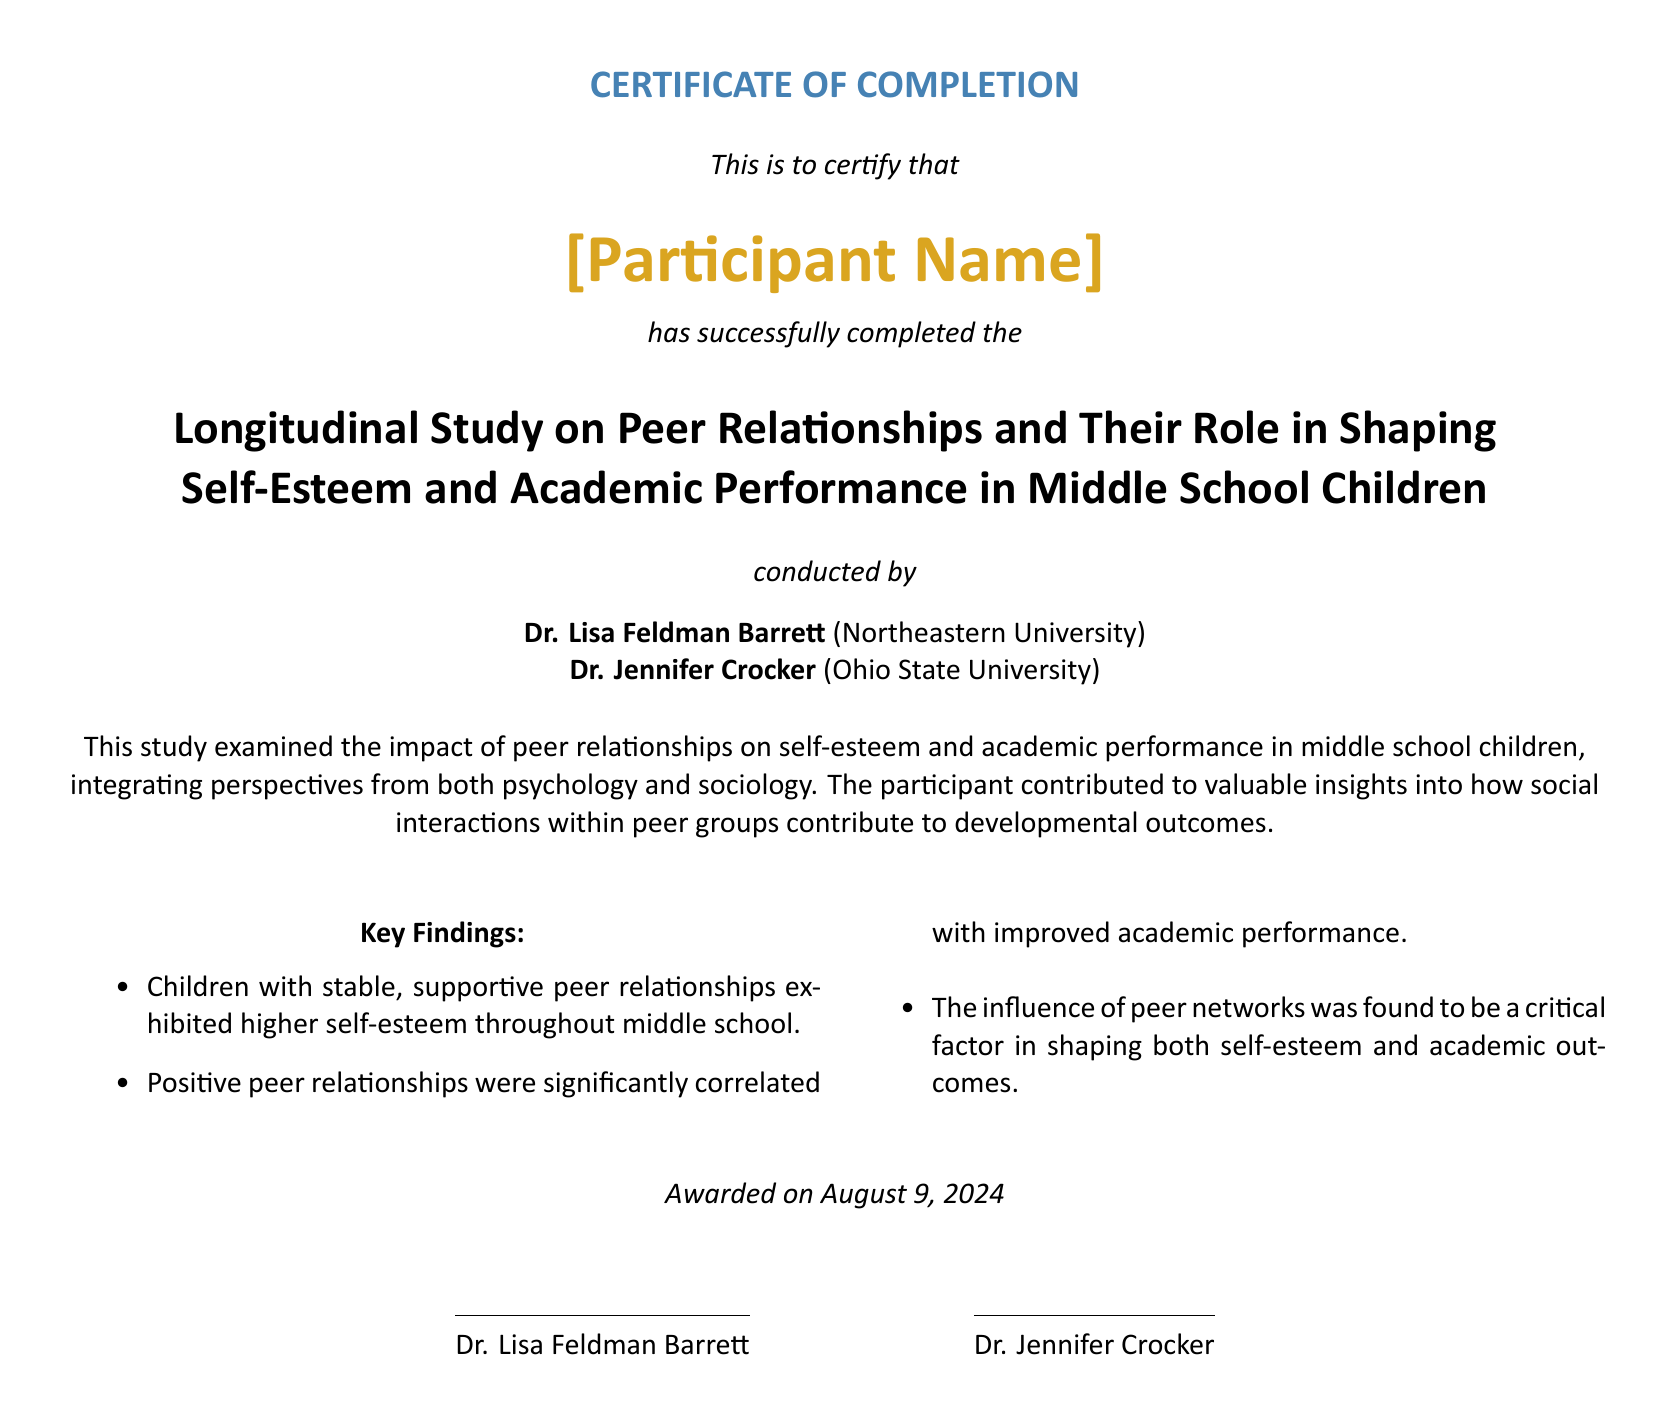What is the name of the participant? The participant's name is in the Diploma under "[Participant Name]."
Answer: [Participant Name] Who conducted the study? The study was conducted by Dr. Lisa Feldman Barrett and Dr. Jennifer Crocker.
Answer: Dr. Lisa Feldman Barrett and Dr. Jennifer Crocker What is the title of the study? The title of the study is stated in the document and is the main focus, involving peer relationships and developmental outcomes.
Answer: Longitudinal Study on Peer Relationships and Their Role in Shaping Self-Esteem and Academic Performance in Middle School Children What date was the certificate awarded? The date awarded is marked as "\today," indicating the current date at the time of document rendering.
Answer: \today What were the key findings? The document includes a summary of findings, specifically relating to self-esteem and academic performance linked to peer relationships.
Answer: Stable, supportive peer relationships; positive correlation; critical factor How many sections are there in the findings? The key findings section is structured in a bulleted list, indicating a specific number of observations.
Answer: Three What is the font used in the document? The document specifies the main font used in its presentation, leading to a distinctive visual format.
Answer: Calibri What colors are used in the document? The document includes specific RGB color values that inform the design and presentation visually.
Answer: psychblue and psychgold 